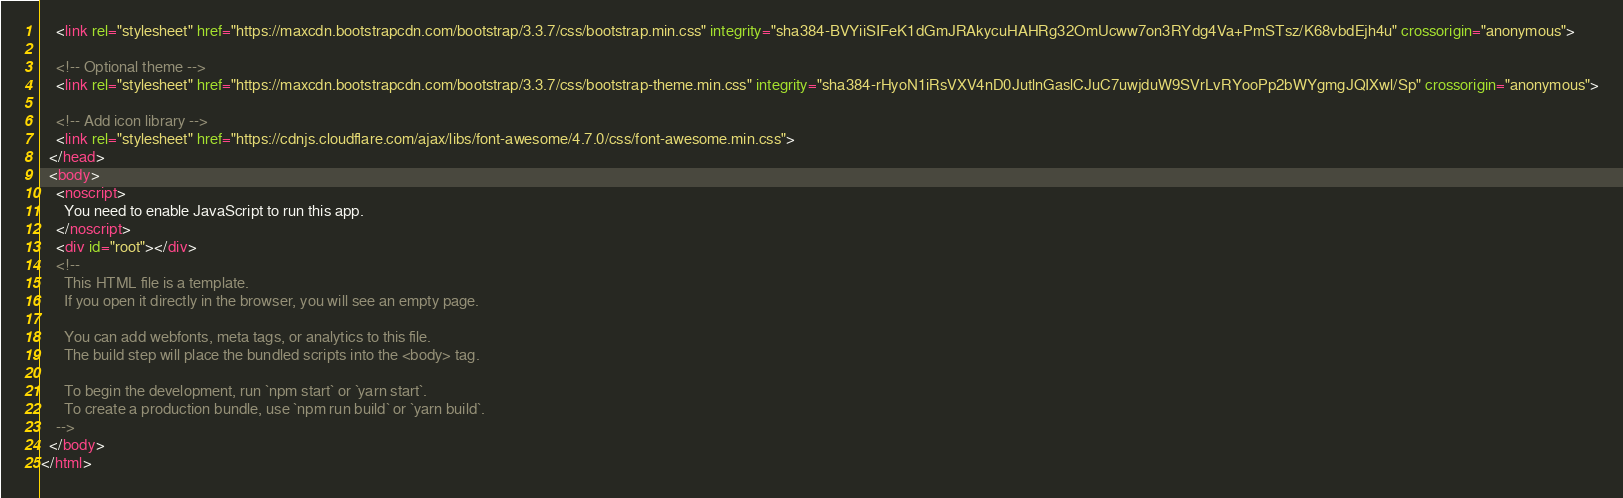Convert code to text. <code><loc_0><loc_0><loc_500><loc_500><_HTML_>    <link rel="stylesheet" href="https://maxcdn.bootstrapcdn.com/bootstrap/3.3.7/css/bootstrap.min.css" integrity="sha384-BVYiiSIFeK1dGmJRAkycuHAHRg32OmUcww7on3RYdg4Va+PmSTsz/K68vbdEjh4u" crossorigin="anonymous">

    <!-- Optional theme -->
    <link rel="stylesheet" href="https://maxcdn.bootstrapcdn.com/bootstrap/3.3.7/css/bootstrap-theme.min.css" integrity="sha384-rHyoN1iRsVXV4nD0JutlnGaslCJuC7uwjduW9SVrLvRYooPp2bWYgmgJQIXwl/Sp" crossorigin="anonymous">

    <!-- Add icon library -->
    <link rel="stylesheet" href="https://cdnjs.cloudflare.com/ajax/libs/font-awesome/4.7.0/css/font-awesome.min.css">
  </head>
  <body>
    <noscript>
      You need to enable JavaScript to run this app.
    </noscript>
    <div id="root"></div>
    <!--
      This HTML file is a template.
      If you open it directly in the browser, you will see an empty page.

      You can add webfonts, meta tags, or analytics to this file.
      The build step will place the bundled scripts into the <body> tag.

      To begin the development, run `npm start` or `yarn start`.
      To create a production bundle, use `npm run build` or `yarn build`.
    -->
  </body>
</html>
</code> 